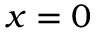<formula> <loc_0><loc_0><loc_500><loc_500>x = 0</formula> 